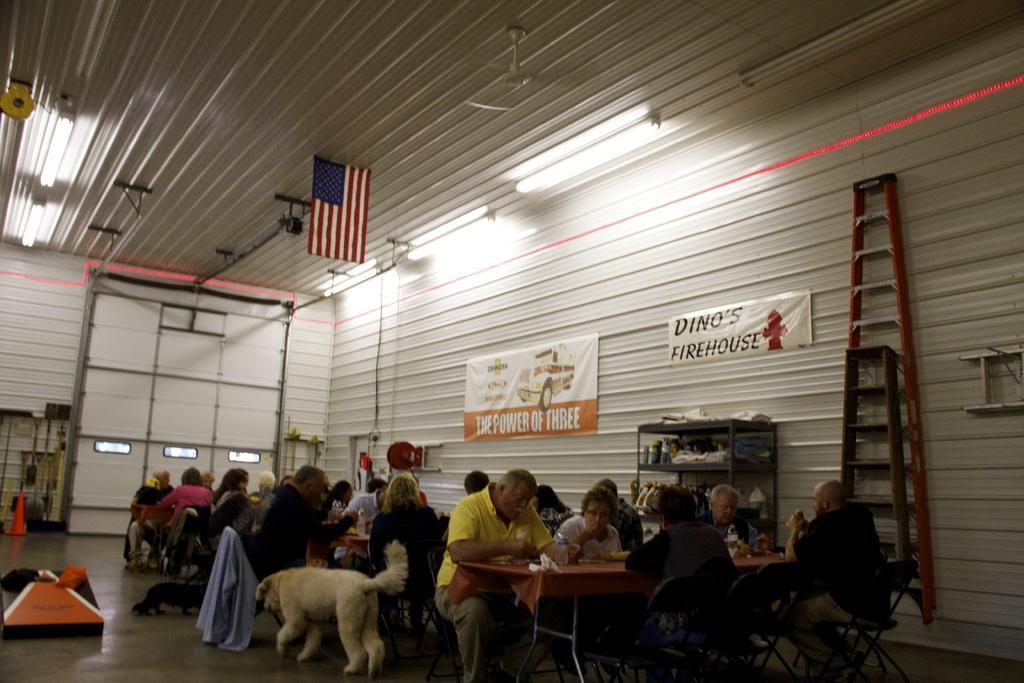In one or two sentences, can you explain what this image depicts? this picture shows a few people seated and eating food on the table, and we see a dog and a flag hanging to the roof 